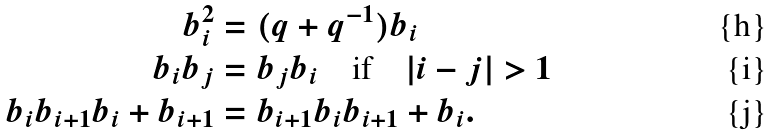<formula> <loc_0><loc_0><loc_500><loc_500>b _ { i } ^ { 2 } & = ( q + q ^ { - 1 } ) b _ { i } \\ b _ { i } b _ { j } & = b _ { j } b _ { i } \quad \text {if} \quad | i - j | > 1 \\ b _ { i } b _ { i + 1 } b _ { i } + b _ { i + 1 } & = b _ { i + 1 } b _ { i } b _ { i + 1 } + b _ { i } .</formula> 